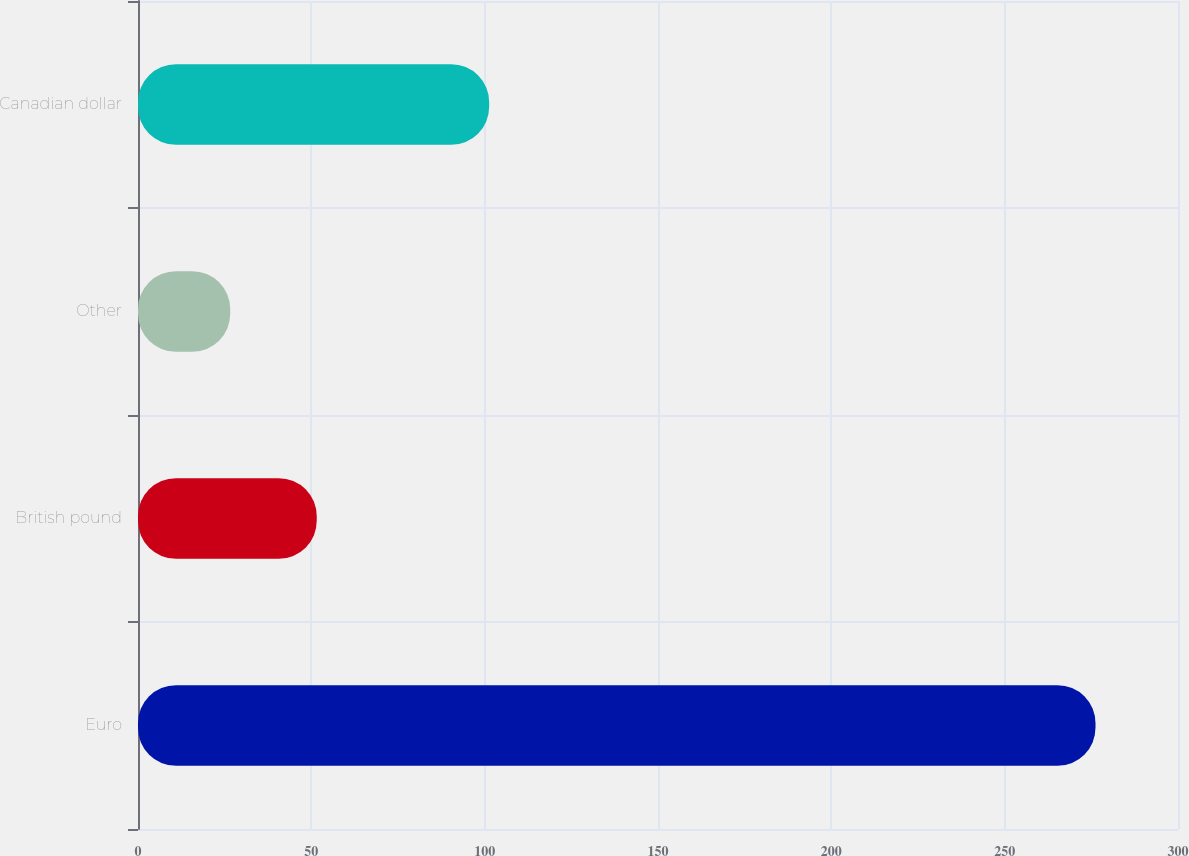<chart> <loc_0><loc_0><loc_500><loc_500><bar_chart><fcel>Euro<fcel>British pound<fcel>Other<fcel>Canadian dollar<nl><fcel>276.2<fcel>51.56<fcel>26.6<fcel>101.3<nl></chart> 